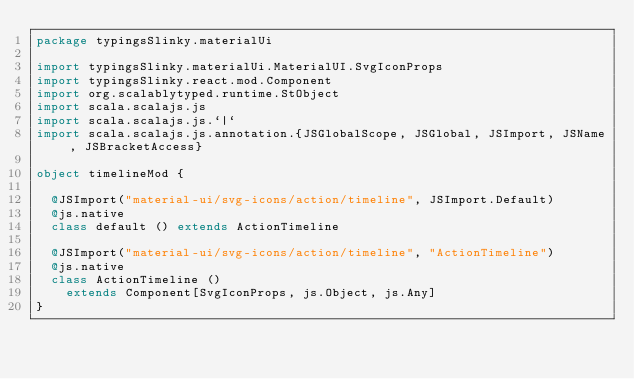Convert code to text. <code><loc_0><loc_0><loc_500><loc_500><_Scala_>package typingsSlinky.materialUi

import typingsSlinky.materialUi.MaterialUI.SvgIconProps
import typingsSlinky.react.mod.Component
import org.scalablytyped.runtime.StObject
import scala.scalajs.js
import scala.scalajs.js.`|`
import scala.scalajs.js.annotation.{JSGlobalScope, JSGlobal, JSImport, JSName, JSBracketAccess}

object timelineMod {
  
  @JSImport("material-ui/svg-icons/action/timeline", JSImport.Default)
  @js.native
  class default () extends ActionTimeline
  
  @JSImport("material-ui/svg-icons/action/timeline", "ActionTimeline")
  @js.native
  class ActionTimeline ()
    extends Component[SvgIconProps, js.Object, js.Any]
}
</code> 